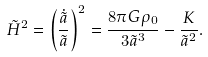<formula> <loc_0><loc_0><loc_500><loc_500>\tilde { H } ^ { 2 } = \left ( \frac { \dot { \tilde { a } } } { \tilde { a } } \right ) ^ { 2 } = \frac { 8 \pi G \rho _ { 0 } } { 3 \tilde { a } ^ { 3 } } - \frac { K } { \tilde { a } ^ { 2 } } .</formula> 